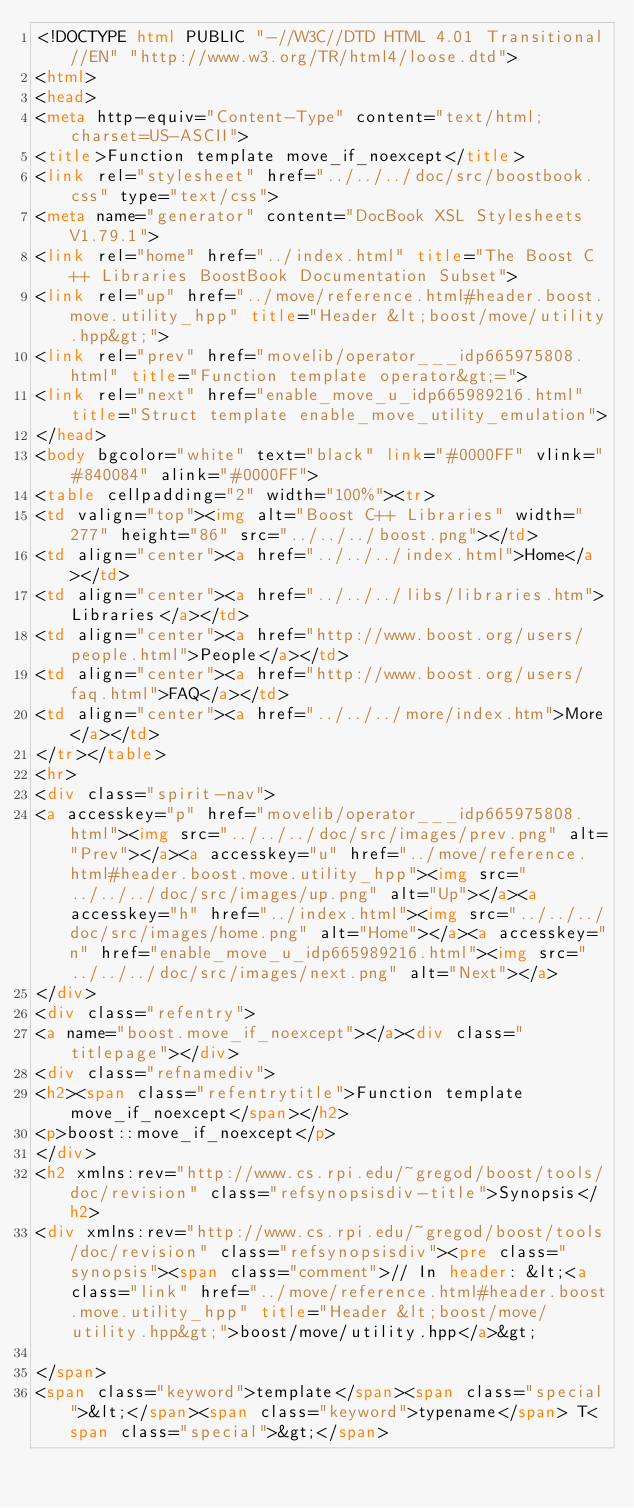Convert code to text. <code><loc_0><loc_0><loc_500><loc_500><_HTML_><!DOCTYPE html PUBLIC "-//W3C//DTD HTML 4.01 Transitional//EN" "http://www.w3.org/TR/html4/loose.dtd">
<html>
<head>
<meta http-equiv="Content-Type" content="text/html; charset=US-ASCII">
<title>Function template move_if_noexcept</title>
<link rel="stylesheet" href="../../../doc/src/boostbook.css" type="text/css">
<meta name="generator" content="DocBook XSL Stylesheets V1.79.1">
<link rel="home" href="../index.html" title="The Boost C++ Libraries BoostBook Documentation Subset">
<link rel="up" href="../move/reference.html#header.boost.move.utility_hpp" title="Header &lt;boost/move/utility.hpp&gt;">
<link rel="prev" href="movelib/operator___idp665975808.html" title="Function template operator&gt;=">
<link rel="next" href="enable_move_u_idp665989216.html" title="Struct template enable_move_utility_emulation">
</head>
<body bgcolor="white" text="black" link="#0000FF" vlink="#840084" alink="#0000FF">
<table cellpadding="2" width="100%"><tr>
<td valign="top"><img alt="Boost C++ Libraries" width="277" height="86" src="../../../boost.png"></td>
<td align="center"><a href="../../../index.html">Home</a></td>
<td align="center"><a href="../../../libs/libraries.htm">Libraries</a></td>
<td align="center"><a href="http://www.boost.org/users/people.html">People</a></td>
<td align="center"><a href="http://www.boost.org/users/faq.html">FAQ</a></td>
<td align="center"><a href="../../../more/index.htm">More</a></td>
</tr></table>
<hr>
<div class="spirit-nav">
<a accesskey="p" href="movelib/operator___idp665975808.html"><img src="../../../doc/src/images/prev.png" alt="Prev"></a><a accesskey="u" href="../move/reference.html#header.boost.move.utility_hpp"><img src="../../../doc/src/images/up.png" alt="Up"></a><a accesskey="h" href="../index.html"><img src="../../../doc/src/images/home.png" alt="Home"></a><a accesskey="n" href="enable_move_u_idp665989216.html"><img src="../../../doc/src/images/next.png" alt="Next"></a>
</div>
<div class="refentry">
<a name="boost.move_if_noexcept"></a><div class="titlepage"></div>
<div class="refnamediv">
<h2><span class="refentrytitle">Function template move_if_noexcept</span></h2>
<p>boost::move_if_noexcept</p>
</div>
<h2 xmlns:rev="http://www.cs.rpi.edu/~gregod/boost/tools/doc/revision" class="refsynopsisdiv-title">Synopsis</h2>
<div xmlns:rev="http://www.cs.rpi.edu/~gregod/boost/tools/doc/revision" class="refsynopsisdiv"><pre class="synopsis"><span class="comment">// In header: &lt;<a class="link" href="../move/reference.html#header.boost.move.utility_hpp" title="Header &lt;boost/move/utility.hpp&gt;">boost/move/utility.hpp</a>&gt;

</span>
<span class="keyword">template</span><span class="special">&lt;</span><span class="keyword">typename</span> T<span class="special">&gt;</span> </code> 